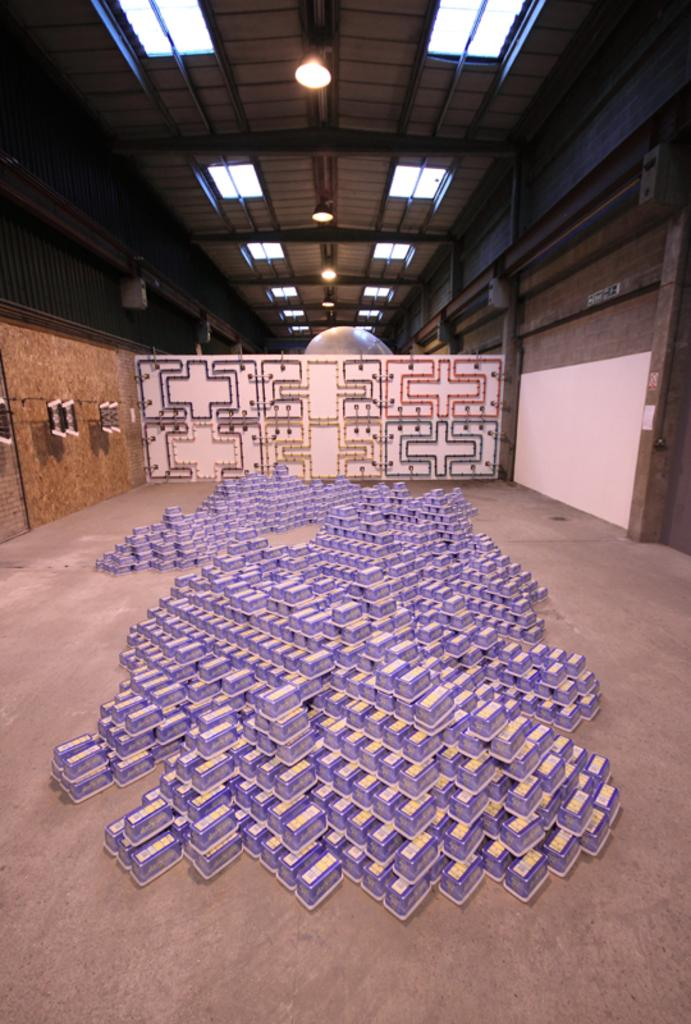What objects are present in the image? There are boxes in the image. How are the boxes arranged? The boxes are stacked one upon the other. Where are the boxes located? The boxes are on the floor. What can be seen behind the boxes? There is a wall with a design behind the boxes. What is attached to the roof in the image? Lights are attached to the roof. What year is depicted on the metal plate in the image? There is no metal plate present in the image, and therefore no year can be identified. 